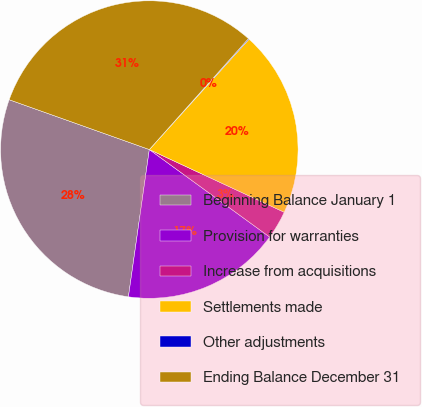Convert chart to OTSL. <chart><loc_0><loc_0><loc_500><loc_500><pie_chart><fcel>Beginning Balance January 1<fcel>Provision for warranties<fcel>Increase from acquisitions<fcel>Settlements made<fcel>Other adjustments<fcel>Ending Balance December 31<nl><fcel>28.19%<fcel>17.24%<fcel>3.08%<fcel>20.23%<fcel>0.09%<fcel>31.17%<nl></chart> 